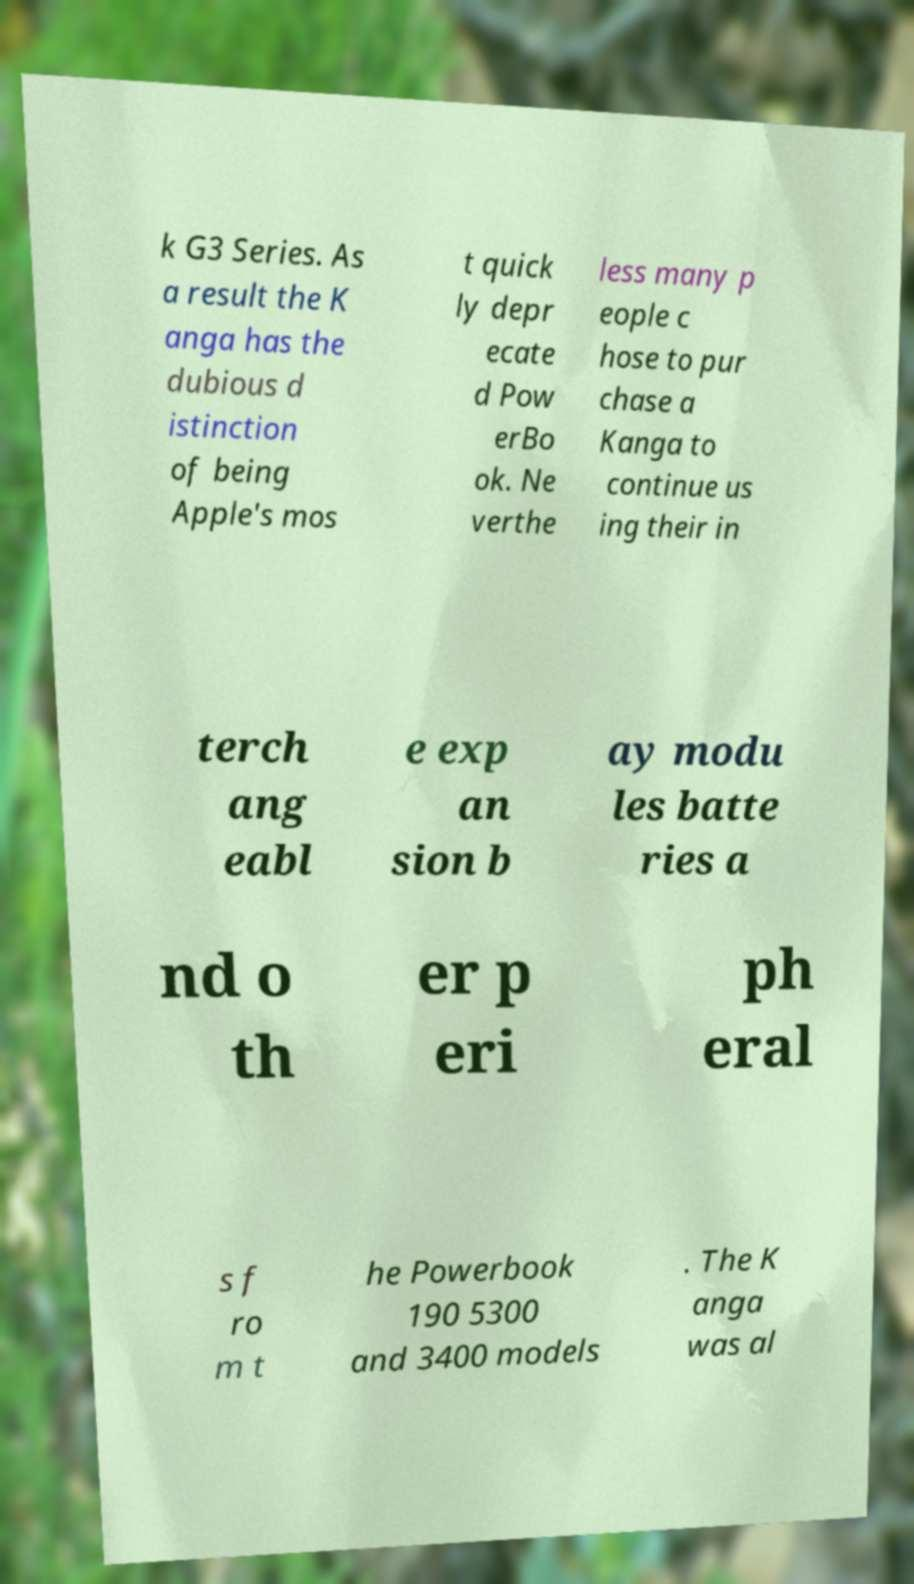Please read and relay the text visible in this image. What does it say? k G3 Series. As a result the K anga has the dubious d istinction of being Apple's mos t quick ly depr ecate d Pow erBo ok. Ne verthe less many p eople c hose to pur chase a Kanga to continue us ing their in terch ang eabl e exp an sion b ay modu les batte ries a nd o th er p eri ph eral s f ro m t he Powerbook 190 5300 and 3400 models . The K anga was al 